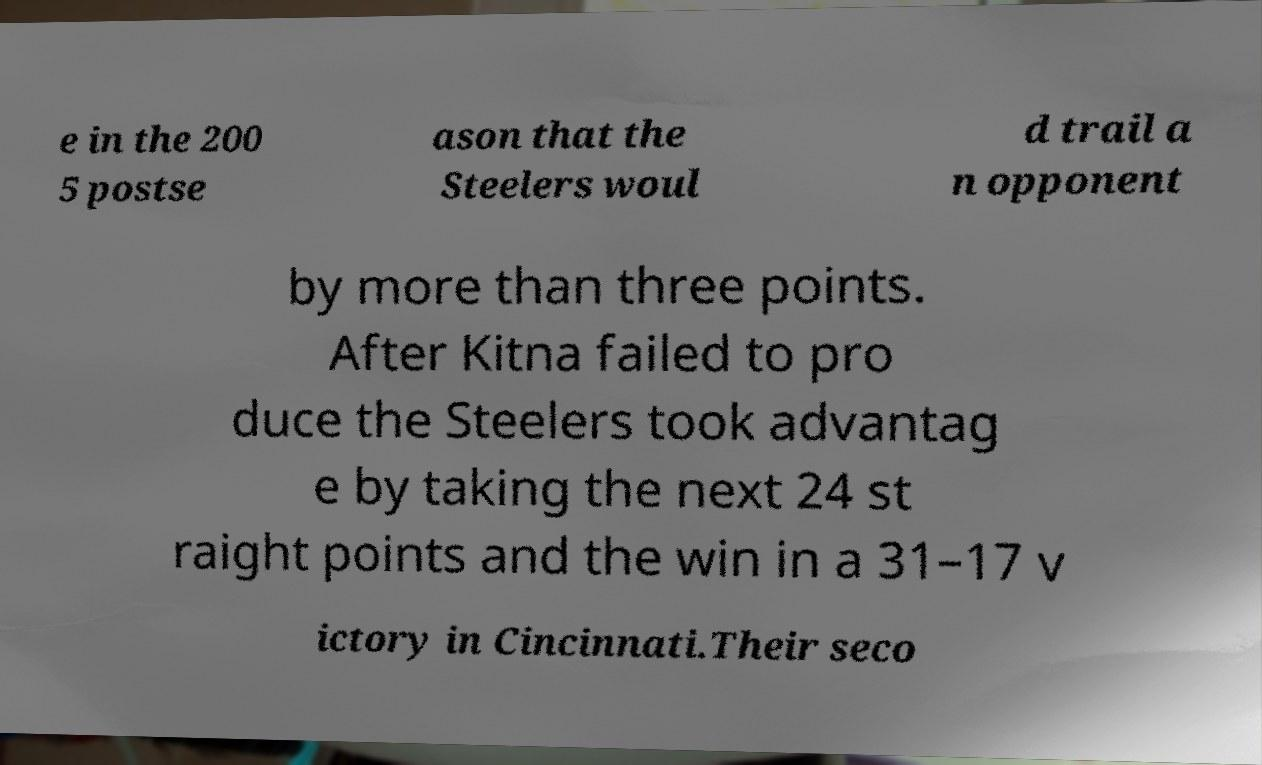Can you read and provide the text displayed in the image?This photo seems to have some interesting text. Can you extract and type it out for me? e in the 200 5 postse ason that the Steelers woul d trail a n opponent by more than three points. After Kitna failed to pro duce the Steelers took advantag e by taking the next 24 st raight points and the win in a 31–17 v ictory in Cincinnati.Their seco 